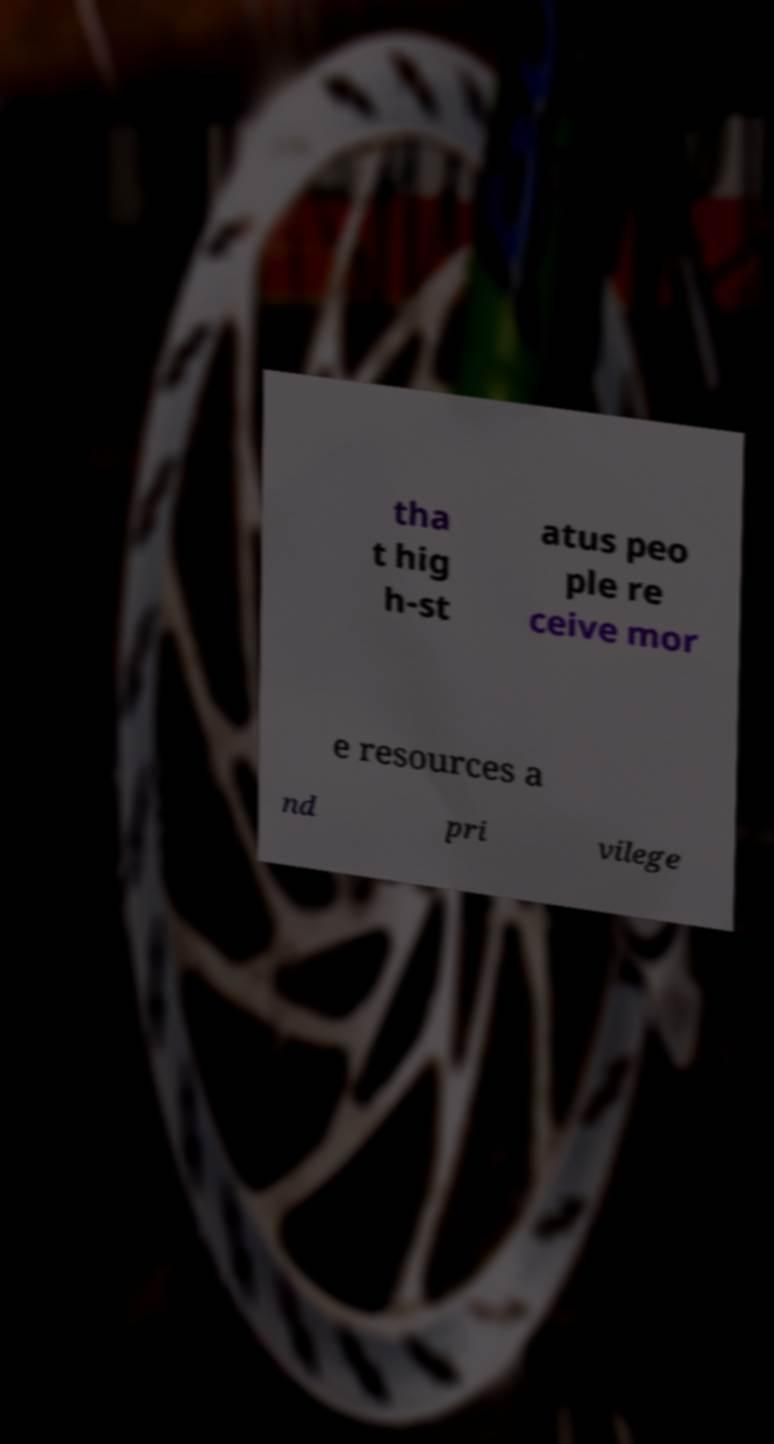Could you assist in decoding the text presented in this image and type it out clearly? tha t hig h-st atus peo ple re ceive mor e resources a nd pri vilege 